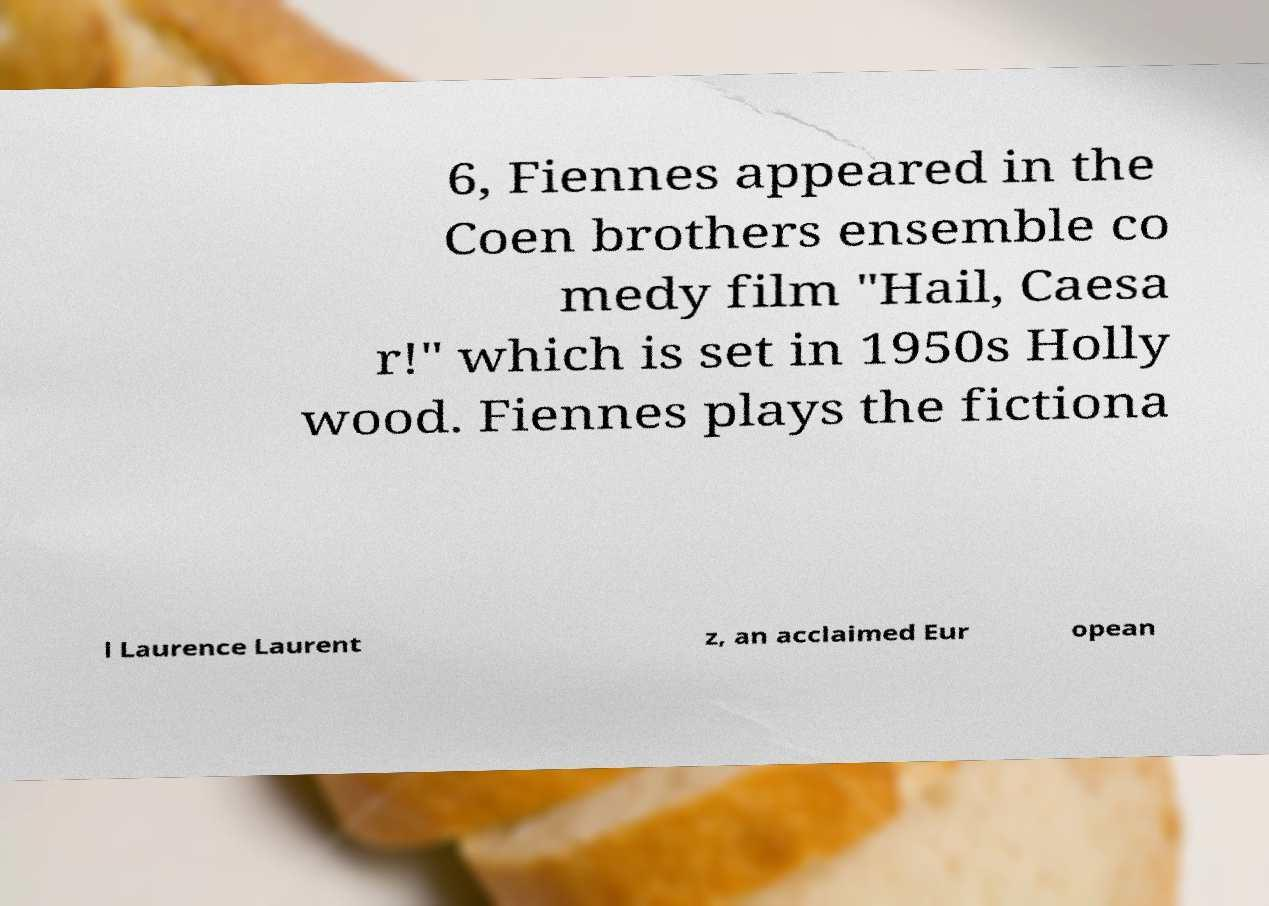There's text embedded in this image that I need extracted. Can you transcribe it verbatim? 6, Fiennes appeared in the Coen brothers ensemble co medy film "Hail, Caesa r!" which is set in 1950s Holly wood. Fiennes plays the fictiona l Laurence Laurent z, an acclaimed Eur opean 